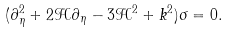Convert formula to latex. <formula><loc_0><loc_0><loc_500><loc_500>( \partial _ { \eta } ^ { 2 } + 2 \mathcal { H } \partial _ { \eta } - 3 \mathcal { H } ^ { 2 } + k ^ { 2 } ) \sigma = 0 .</formula> 